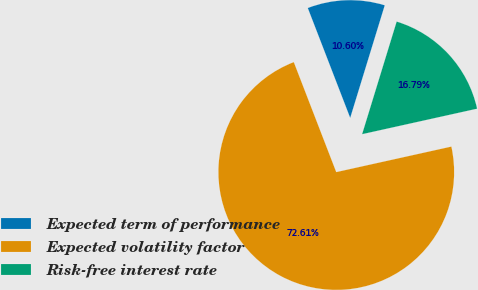<chart> <loc_0><loc_0><loc_500><loc_500><pie_chart><fcel>Expected term of performance<fcel>Expected volatility factor<fcel>Risk-free interest rate<nl><fcel>10.6%<fcel>72.61%<fcel>16.79%<nl></chart> 